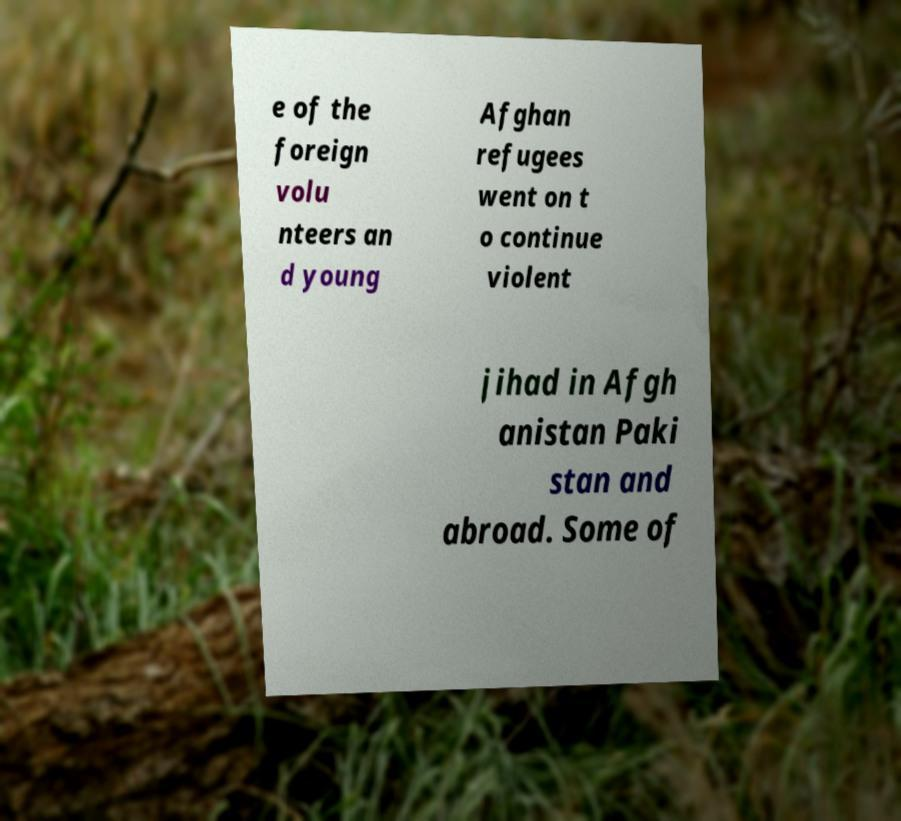What messages or text are displayed in this image? I need them in a readable, typed format. e of the foreign volu nteers an d young Afghan refugees went on t o continue violent jihad in Afgh anistan Paki stan and abroad. Some of 